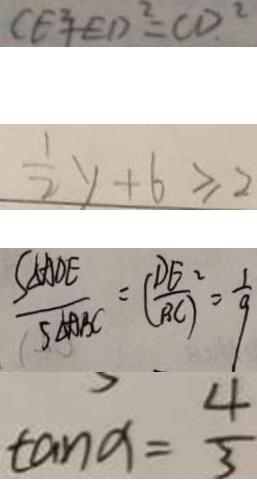Convert formula to latex. <formula><loc_0><loc_0><loc_500><loc_500>C E ^ { 2 } E D ^ { 2 } = C D ^ { 2 } 
 \frac { 1 } { 2 } y + 6 \geq 2 
 \frac { S _ { \Delta } A D E } { S _ { \Delta A B C } } = ( \frac { D E } { B C } ) ^ { 2 } = \frac { 1 } { 9 } 
 \tan a = \frac { 4 } { 3 }</formula> 